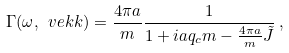<formula> <loc_0><loc_0><loc_500><loc_500>\Gamma ( \omega , \ v e k { k } ) = \frac { 4 \pi a } { m } \frac { 1 } { 1 + i a q _ { c } m - \frac { 4 \pi a } { m } \tilde { J } } \, ,</formula> 